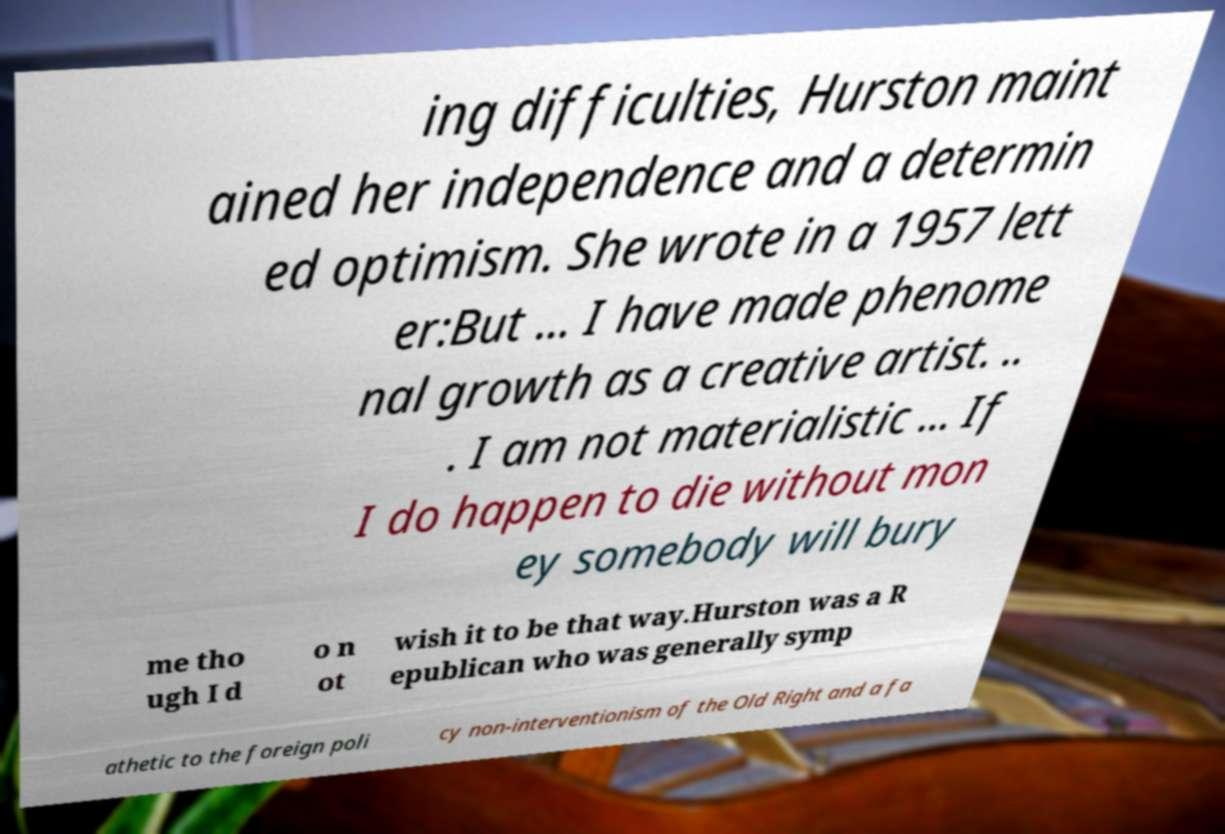Can you accurately transcribe the text from the provided image for me? ing difficulties, Hurston maint ained her independence and a determin ed optimism. She wrote in a 1957 lett er:But ... I have made phenome nal growth as a creative artist. .. . I am not materialistic ... If I do happen to die without mon ey somebody will bury me tho ugh I d o n ot wish it to be that way.Hurston was a R epublican who was generally symp athetic to the foreign poli cy non-interventionism of the Old Right and a fa 